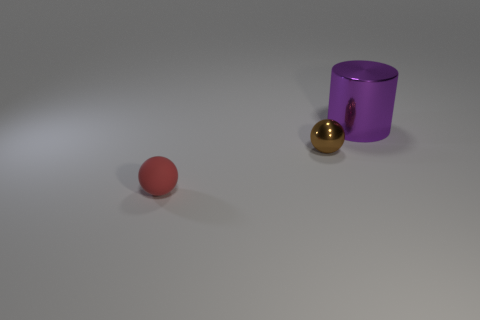Subtract all green cylinders. Subtract all green cubes. How many cylinders are left? 1 Add 3 small matte balls. How many objects exist? 6 Subtract all cylinders. How many objects are left? 2 Add 3 yellow rubber cylinders. How many yellow rubber cylinders exist? 3 Subtract 0 gray spheres. How many objects are left? 3 Subtract all tiny purple shiny balls. Subtract all spheres. How many objects are left? 1 Add 3 rubber objects. How many rubber objects are left? 4 